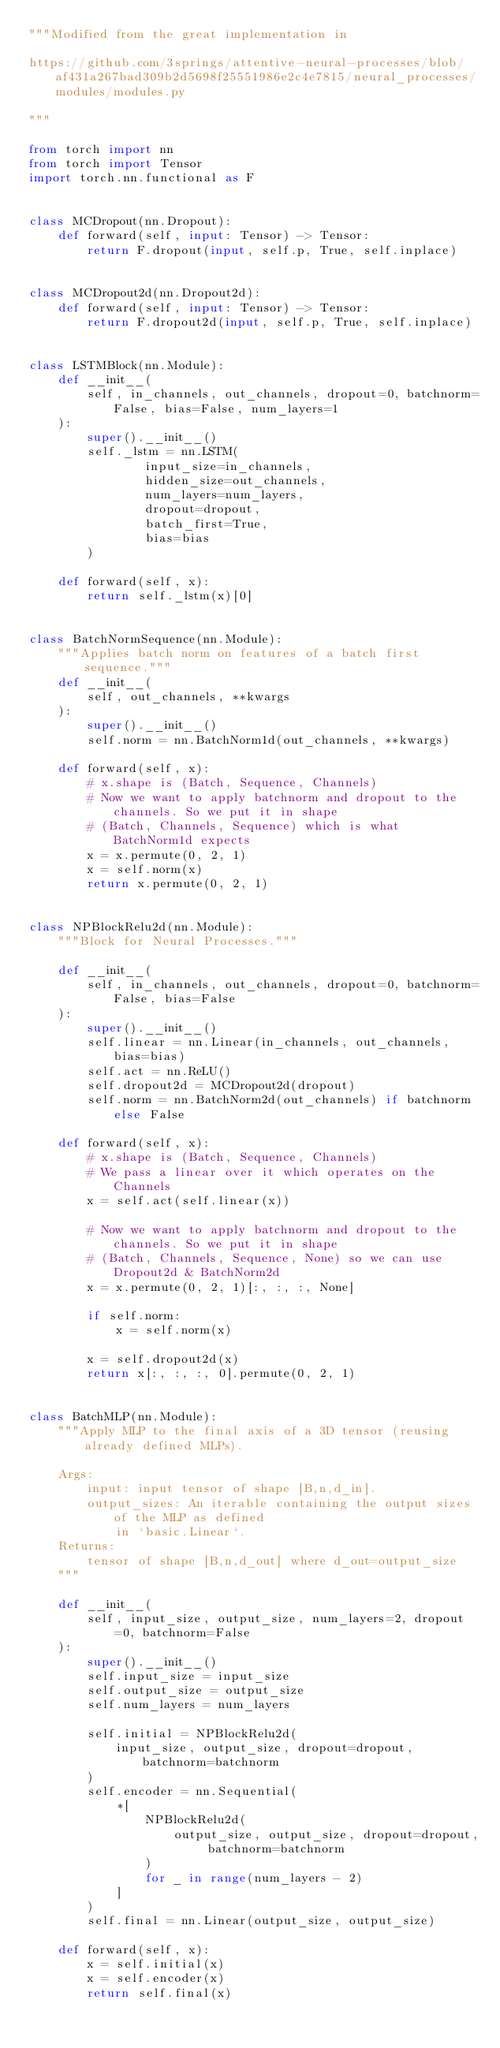Convert code to text. <code><loc_0><loc_0><loc_500><loc_500><_Python_>"""Modified from the great implementation in

https://github.com/3springs/attentive-neural-processes/blob/af431a267bad309b2d5698f25551986e2c4e7815/neural_processes/modules/modules.py

"""

from torch import nn
from torch import Tensor
import torch.nn.functional as F


class MCDropout(nn.Dropout):
    def forward(self, input: Tensor) -> Tensor:
        return F.dropout(input, self.p, True, self.inplace)


class MCDropout2d(nn.Dropout2d):
    def forward(self, input: Tensor) -> Tensor:
        return F.dropout2d(input, self.p, True, self.inplace)


class LSTMBlock(nn.Module):
    def __init__(
        self, in_channels, out_channels, dropout=0, batchnorm=False, bias=False, num_layers=1
    ):
        super().__init__()
        self._lstm = nn.LSTM(
                input_size=in_channels,
                hidden_size=out_channels,
                num_layers=num_layers,
                dropout=dropout,
                batch_first=True,
                bias=bias
        )

    def forward(self, x):
        return self._lstm(x)[0]


class BatchNormSequence(nn.Module):
    """Applies batch norm on features of a batch first sequence."""
    def __init__(
        self, out_channels, **kwargs
    ):
        super().__init__()
        self.norm = nn.BatchNorm1d(out_channels, **kwargs)

    def forward(self, x):
        # x.shape is (Batch, Sequence, Channels)
        # Now we want to apply batchnorm and dropout to the channels. So we put it in shape
        # (Batch, Channels, Sequence) which is what BatchNorm1d expects
        x = x.permute(0, 2, 1)
        x = self.norm(x)
        return x.permute(0, 2, 1)


class NPBlockRelu2d(nn.Module):
    """Block for Neural Processes."""

    def __init__(
        self, in_channels, out_channels, dropout=0, batchnorm=False, bias=False
    ):
        super().__init__()
        self.linear = nn.Linear(in_channels, out_channels, bias=bias)
        self.act = nn.ReLU()
        self.dropout2d = MCDropout2d(dropout)
        self.norm = nn.BatchNorm2d(out_channels) if batchnorm else False

    def forward(self, x):
        # x.shape is (Batch, Sequence, Channels)
        # We pass a linear over it which operates on the Channels
        x = self.act(self.linear(x))

        # Now we want to apply batchnorm and dropout to the channels. So we put it in shape
        # (Batch, Channels, Sequence, None) so we can use Dropout2d & BatchNorm2d
        x = x.permute(0, 2, 1)[:, :, :, None]

        if self.norm:
            x = self.norm(x)

        x = self.dropout2d(x)
        return x[:, :, :, 0].permute(0, 2, 1)


class BatchMLP(nn.Module):
    """Apply MLP to the final axis of a 3D tensor (reusing already defined MLPs).

    Args:
        input: input tensor of shape [B,n,d_in].
        output_sizes: An iterable containing the output sizes of the MLP as defined
            in `basic.Linear`.
    Returns:
        tensor of shape [B,n,d_out] where d_out=output_size
    """

    def __init__(
        self, input_size, output_size, num_layers=2, dropout=0, batchnorm=False
    ):
        super().__init__()
        self.input_size = input_size
        self.output_size = output_size
        self.num_layers = num_layers

        self.initial = NPBlockRelu2d(
            input_size, output_size, dropout=dropout, batchnorm=batchnorm
        )
        self.encoder = nn.Sequential(
            *[
                NPBlockRelu2d(
                    output_size, output_size, dropout=dropout, batchnorm=batchnorm
                )
                for _ in range(num_layers - 2)
            ]
        )
        self.final = nn.Linear(output_size, output_size)

    def forward(self, x):
        x = self.initial(x)
        x = self.encoder(x)
        return self.final(x)

</code> 